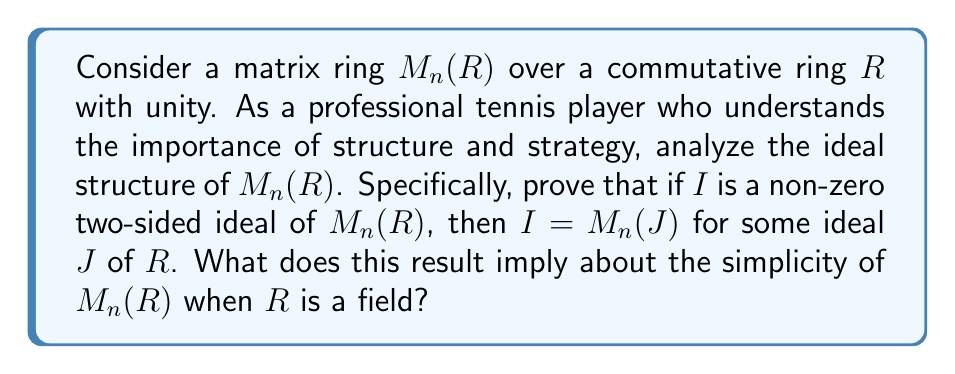Give your solution to this math problem. Let's approach this step-by-step:

1) First, let $I$ be a non-zero two-sided ideal of $M_n(R)$.

2) Define $J = \{r \in R : rE_{ij} \in I \text{ for some } i,j\}$, where $E_{ij}$ is the matrix with 1 in the $(i,j)$-th position and 0 elsewhere.

3) We need to show that $J$ is an ideal of $R$:
   - If $a,b \in J$, then $aE_{ij}, bE_{kl} \in I$ for some $i,j,k,l$. Since $I$ is an ideal, $(a+b)E_{ij} = aE_{ij} + bE_{ij} \in I$, so $a+b \in J$.
   - If $a \in J$ and $r \in R$, then $aE_{ij} \in I$ for some $i,j$. Since $I$ is an ideal, $r(aE_{ij}) = (ra)E_{ij} \in I$, so $ra \in J$.

4) Now, we need to show that $I = M_n(J)$:
   - If $A = (a_{ij}) \in I$, then $a_{ij}E_{ij} = E_{ii}AE_{jj} \in I$ for all $i,j$. Thus, $a_{ij} \in J$ for all $i,j$, so $A \in M_n(J)$.
   - Conversely, if $A = (a_{ij}) \in M_n(J)$, then $a_{ij} \in J$ for all $i,j$. So $a_{ij}E_{ij} \in I$ for all $i,j$. Since $I$ is an ideal, $A = \sum_{i,j} a_{ij}E_{ij} \in I$.

5) This proves that $I = M_n(J)$ for some ideal $J$ of $R$.

6) Now, if $R$ is a field, its only ideals are $\{0\}$ and $R$ itself. Therefore, the only ideals of $M_n(R)$ are $\{0\}$ and $M_n(R)$ itself.

7) By definition, a non-zero ring with no non-trivial two-sided ideals is simple.

Therefore, when $R$ is a field, $M_n(R)$ is a simple ring.
Answer: When $R$ is a field, $M_n(R)$ is a simple ring, meaning it has no non-trivial two-sided ideals. 